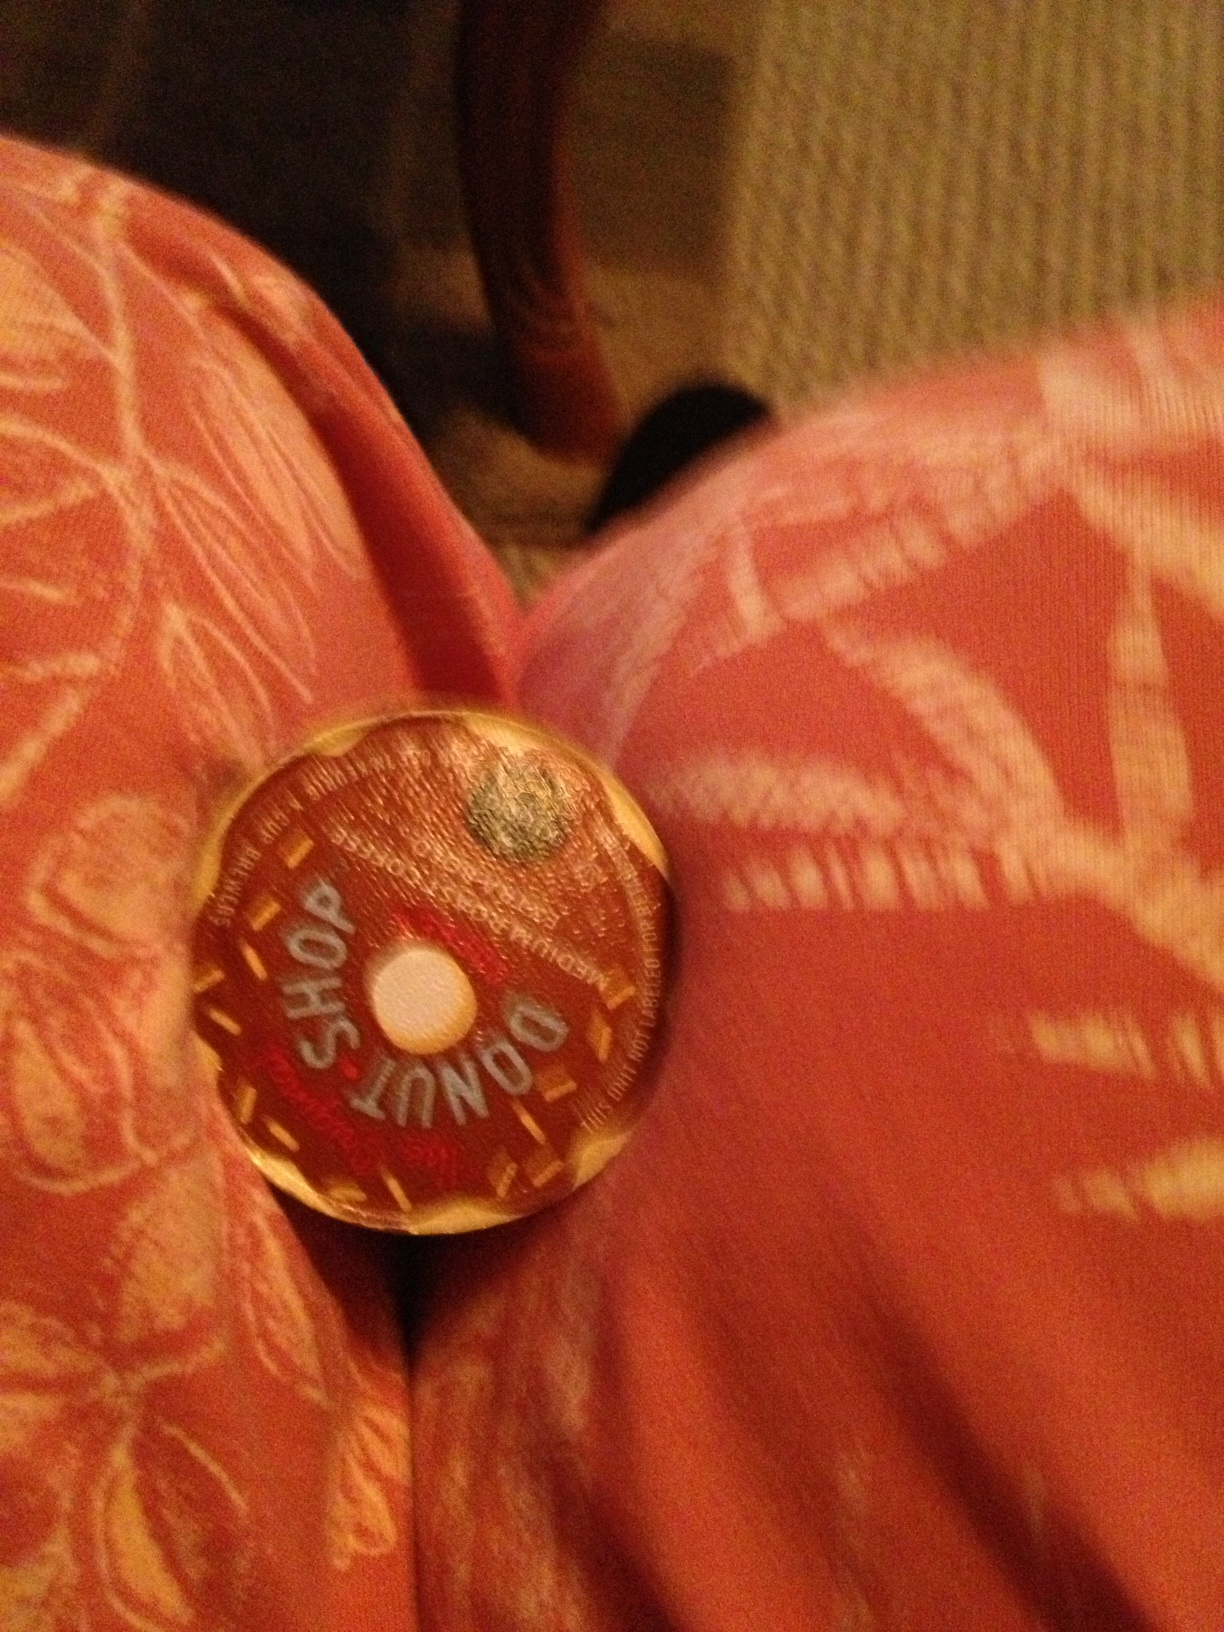Can you describe the taste experience of a Donut Shop coffee? Drinking a cup of Donut Shop coffee is like indulging in a comforting, bakery-fresh treat. The coffee delivers a smooth, medium-bodied taste with a hint of sweetness that isn't overpowering but feels indulgent enough to complement a variety of pastries. Imagine the smell of fresh coffee brewed in a warm, cozy kitchen, mingled with the scent of freshly baked donuts – it's this experience encapsulated in a cup. 